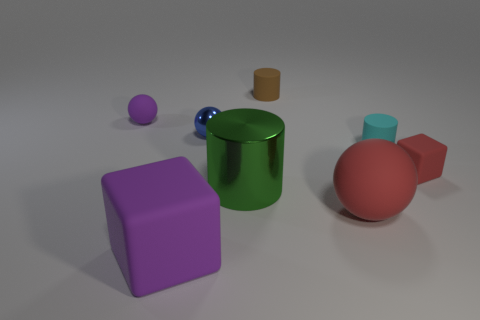Is there a small object that has the same color as the large block?
Ensure brevity in your answer.  Yes. The rubber object that is the same color as the tiny rubber cube is what shape?
Your answer should be very brief. Sphere. Is there any other thing that is the same color as the tiny metal ball?
Your answer should be compact. No. Does the cyan cylinder have the same material as the sphere that is in front of the tiny red block?
Keep it short and to the point. Yes. What material is the tiny purple thing that is the same shape as the small blue shiny thing?
Your response must be concise. Rubber. Is there anything else that has the same material as the small red thing?
Give a very brief answer. Yes. Is the purple thing in front of the blue shiny sphere made of the same material as the purple object behind the large purple rubber thing?
Give a very brief answer. Yes. There is a rubber block in front of the large thing that is behind the ball that is in front of the small red block; what is its color?
Ensure brevity in your answer.  Purple. What number of other objects are the same shape as the blue object?
Offer a very short reply. 2. Do the tiny metallic object and the tiny matte ball have the same color?
Offer a terse response. No. 